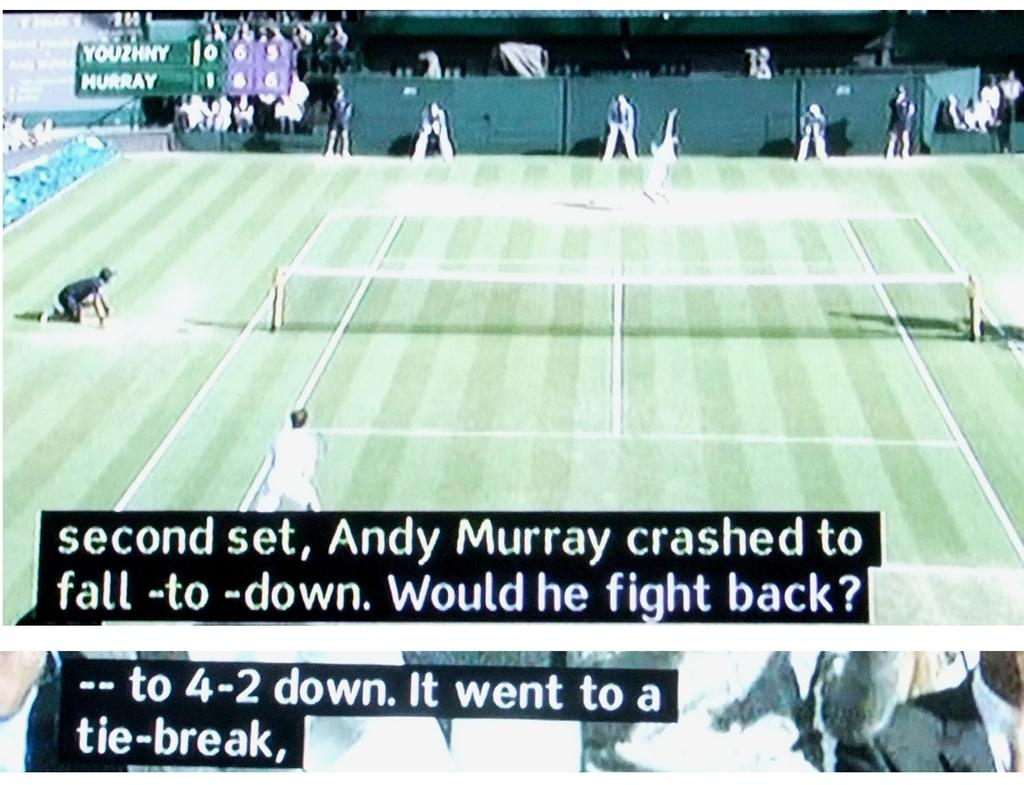<image>
Create a compact narrative representing the image presented. Andy Murray is playing the second set in a tennis game. 